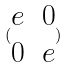<formula> <loc_0><loc_0><loc_500><loc_500>( \begin{matrix} e & 0 \\ 0 & e \end{matrix} )</formula> 